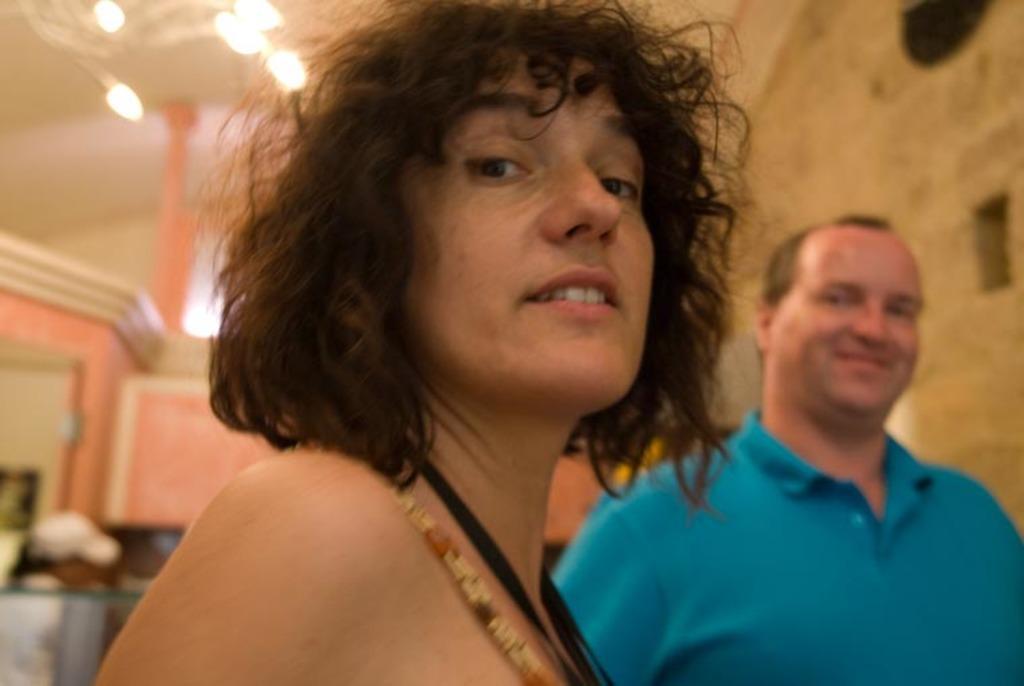Please provide a concise description of this image. In this image we can see two persons one lady and one male person who is wearing blue color T-shirt standing at the background of the image and at the foreground of the image there is lady person's face and at the background of the image there are some lights and wall. 